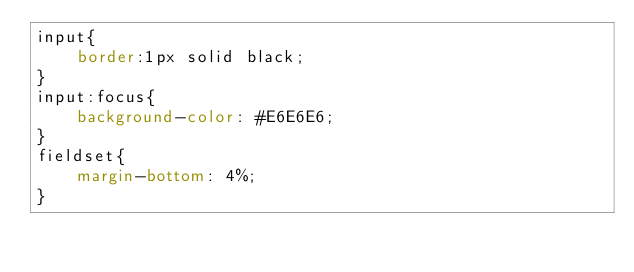Convert code to text. <code><loc_0><loc_0><loc_500><loc_500><_CSS_>input{			
    border:1px solid black;
}		
input:focus{
	background-color: #E6E6E6;		
}
fieldset{
    margin-bottom: 4%;
}	</code> 